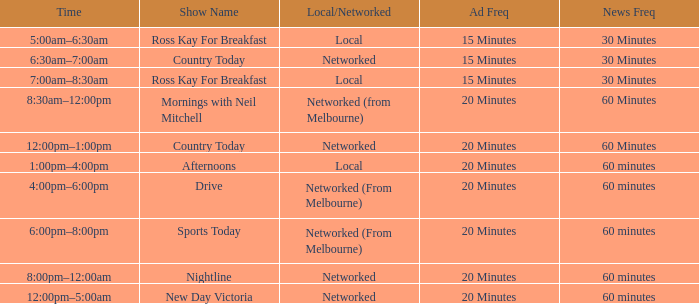What time can one watch the broadcast named mornings with neil mitchell? 8:30am–12:00pm. 